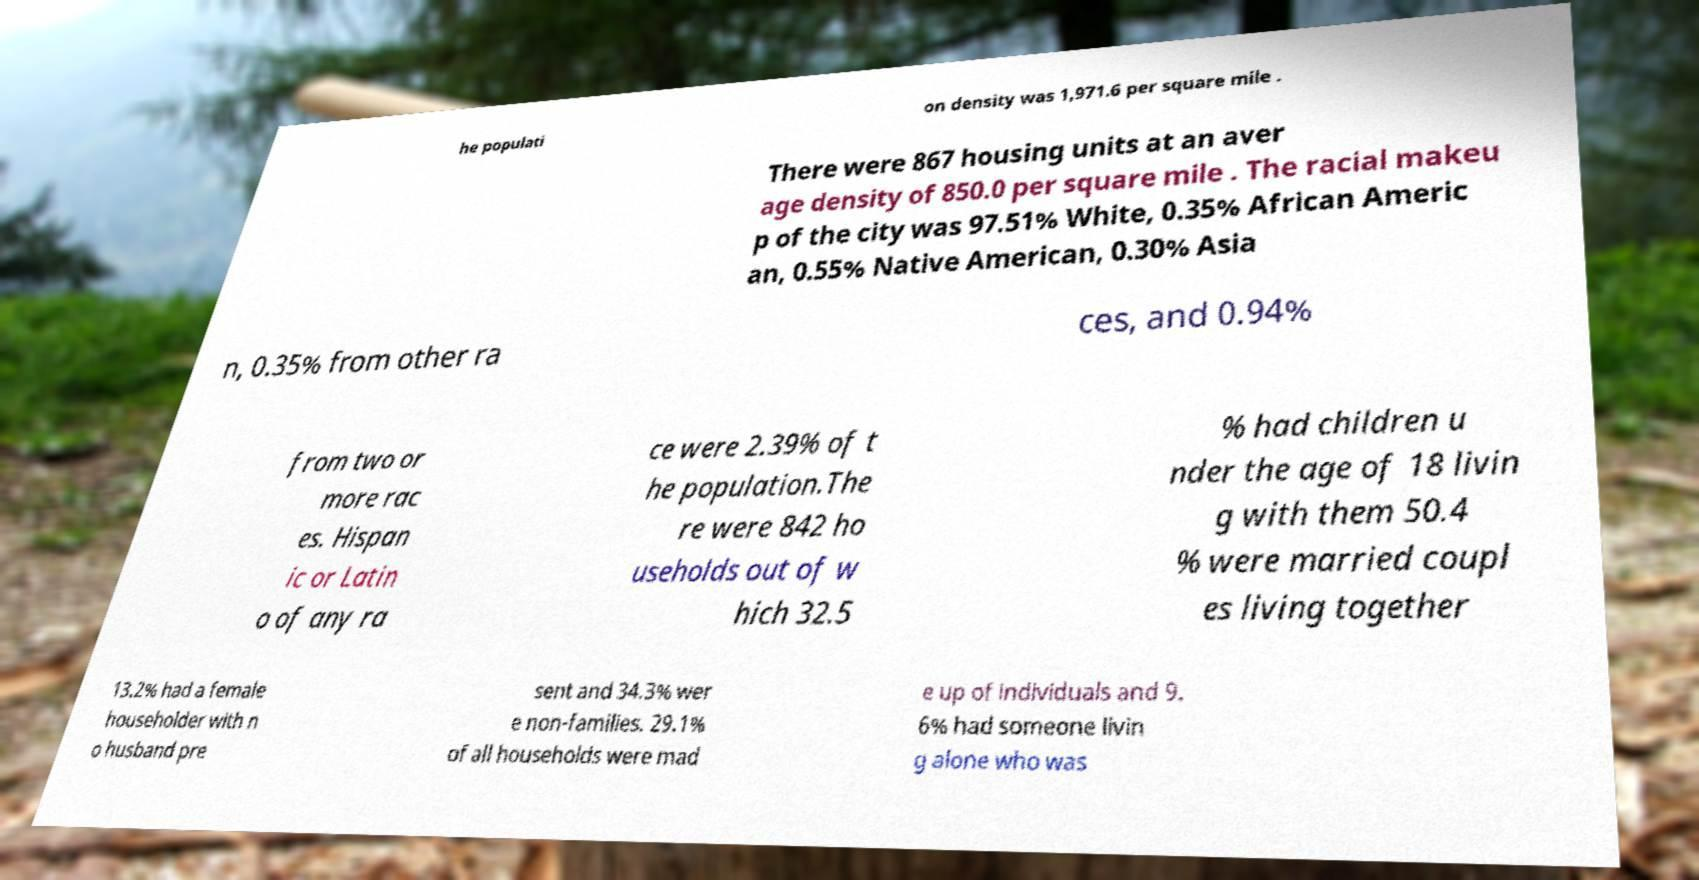Can you accurately transcribe the text from the provided image for me? he populati on density was 1,971.6 per square mile . There were 867 housing units at an aver age density of 850.0 per square mile . The racial makeu p of the city was 97.51% White, 0.35% African Americ an, 0.55% Native American, 0.30% Asia n, 0.35% from other ra ces, and 0.94% from two or more rac es. Hispan ic or Latin o of any ra ce were 2.39% of t he population.The re were 842 ho useholds out of w hich 32.5 % had children u nder the age of 18 livin g with them 50.4 % were married coupl es living together 13.2% had a female householder with n o husband pre sent and 34.3% wer e non-families. 29.1% of all households were mad e up of individuals and 9. 6% had someone livin g alone who was 